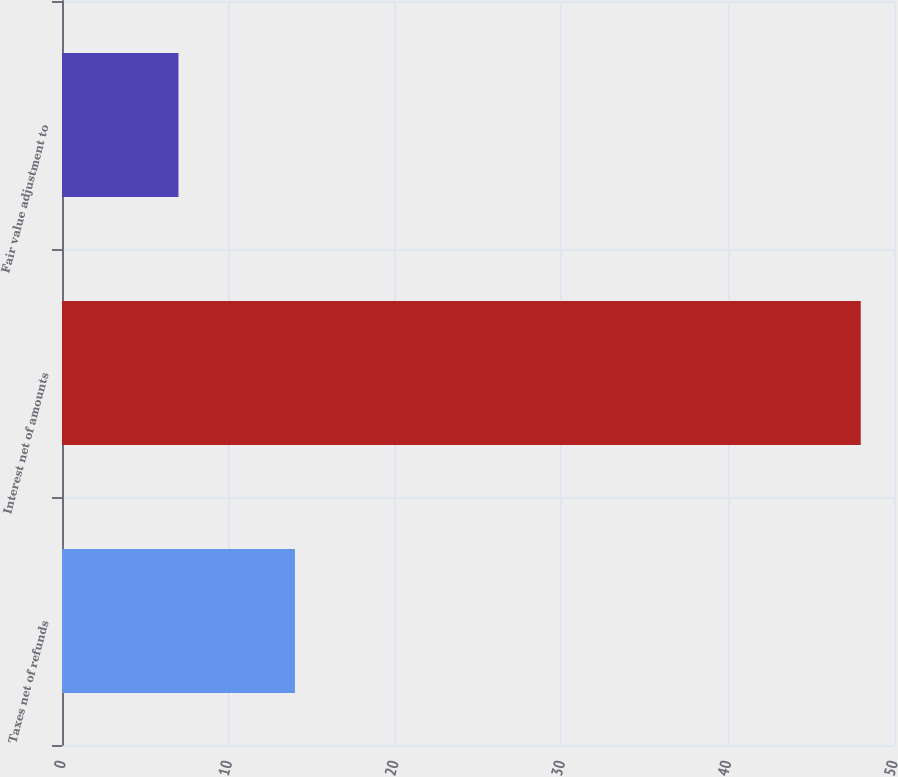Convert chart. <chart><loc_0><loc_0><loc_500><loc_500><bar_chart><fcel>Taxes net of refunds<fcel>Interest net of amounts<fcel>Fair value adjustment to<nl><fcel>14<fcel>48<fcel>7<nl></chart> 